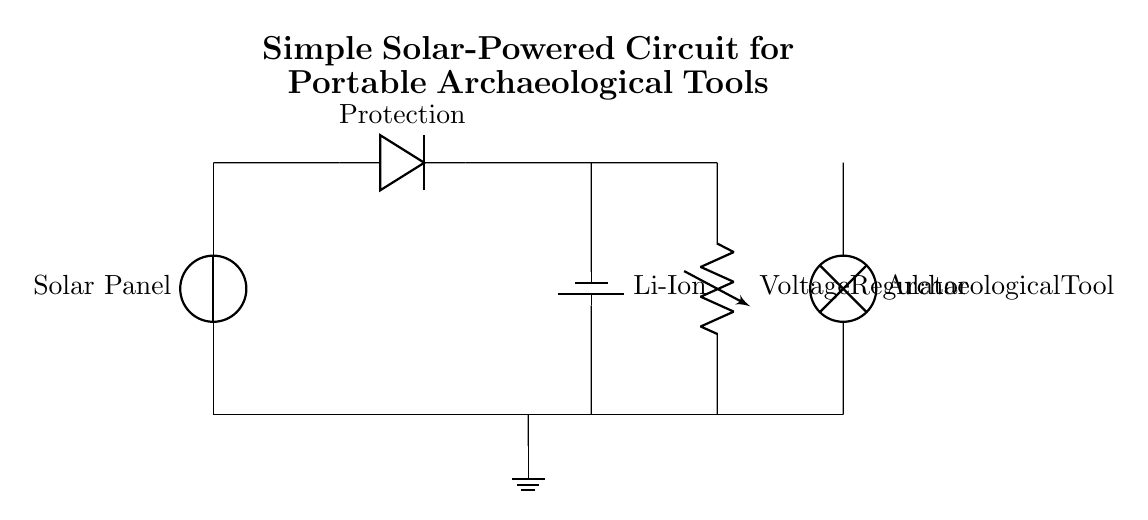What component is used for protection in this circuit? The circuit diagram shows a diode labeled "Protection," which is placed between the solar panel and the battery to prevent reverse current flow.
Answer: Protection What type of battery is used in this circuit? The battery component in the diagram is labeled "Li-Ion," indicating that it is a lithium-ion battery commonly used for portable devices.
Answer: Li-Ion What is the purpose of the voltage regulator in this circuit? The voltage regulator, indicated in the circuit, is used to maintain a steady voltage output to the load (archaeological tool) regardless of variations in input voltage from the battery as it discharges.
Answer: Steady voltage output How many components are there in total in this circuit? By counting the components in the circuit, we see a solar panel, a diode, a battery, a voltage regulator, and a lamp as the load, totaling five distinct components.
Answer: Five What is the load in this circuit powering? The load, specified as "Archaeological Tool" in the diagram, refers to the portable device that requires power to operate, which is directly connected to the output of the voltage regulator.
Answer: Archaeological Tool Which component connects the solar panel to the battery? The connection from the solar panel to the battery is made through a short wire and a diode for protection, indicating direct electrical connectivity.
Answer: Short wire and diode 